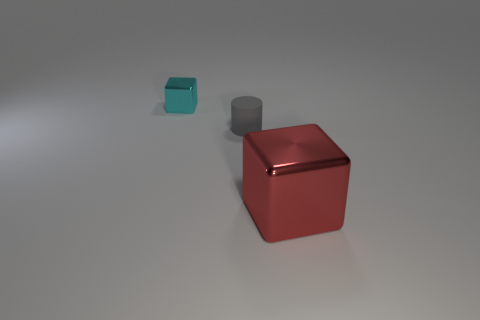Is there any other thing that is the same size as the red thing?
Keep it short and to the point. No. There is a matte cylinder that is the same size as the cyan metallic cube; what color is it?
Make the answer very short. Gray. What is the size of the block to the left of the gray matte cylinder that is left of the red object?
Your answer should be compact. Small. Do the tiny cube and the small object that is in front of the cyan metallic block have the same color?
Offer a terse response. No. Are there fewer small objects on the left side of the gray cylinder than matte balls?
Keep it short and to the point. No. What number of other objects are there of the same size as the gray cylinder?
Make the answer very short. 1. There is a shiny thing behind the red block; is it the same shape as the tiny rubber thing?
Give a very brief answer. No. Are there more tiny gray matte objects that are on the left side of the cylinder than purple rubber things?
Give a very brief answer. No. There is a thing that is both to the left of the large red metallic cube and on the right side of the cyan thing; what material is it?
Keep it short and to the point. Rubber. Is there anything else that is the same shape as the tiny cyan object?
Provide a short and direct response. Yes. 